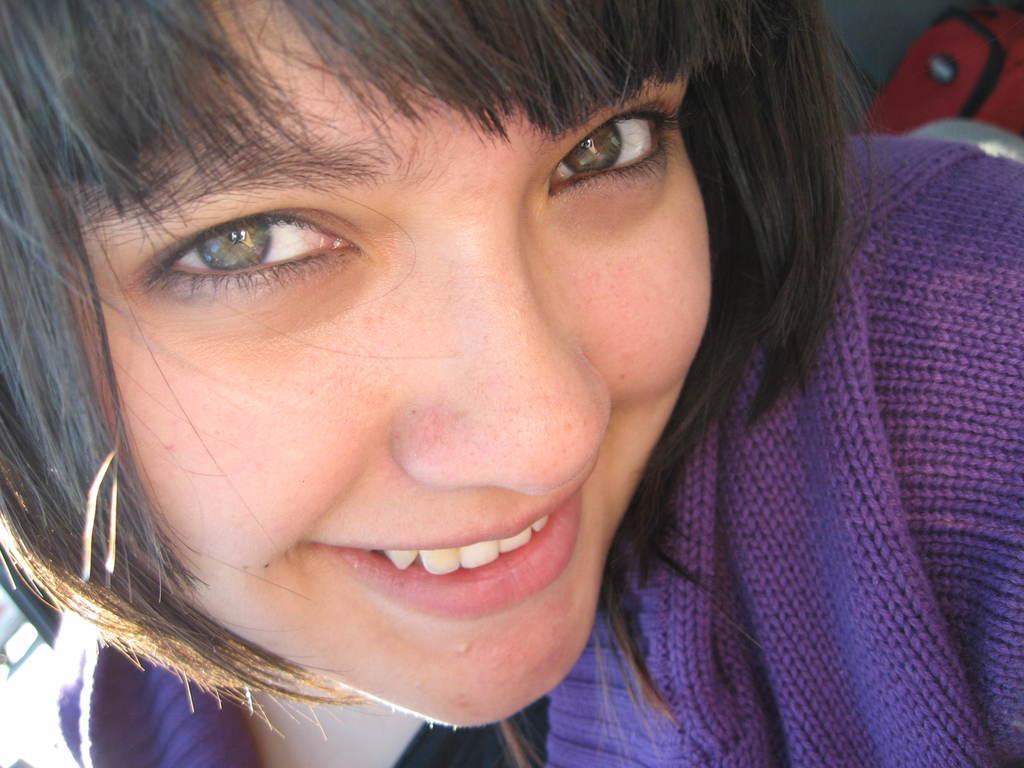In one or two sentences, can you explain what this image depicts? In this image I can see a person wearing purple color dress. Background I can see a red color bag 